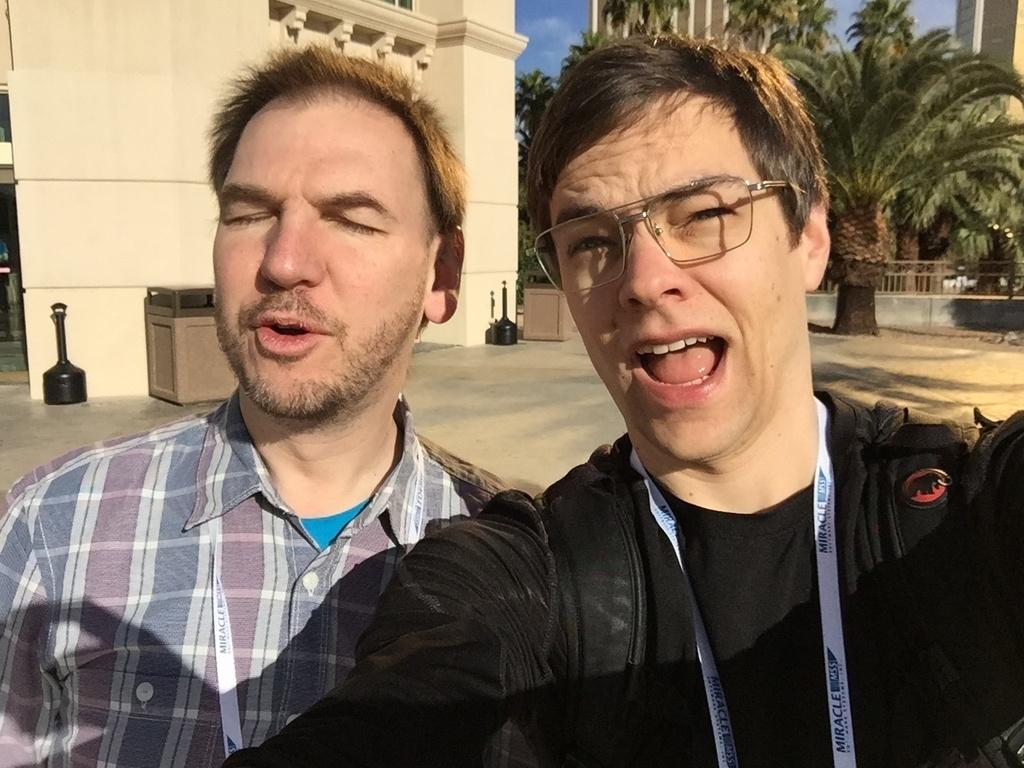How many people are in the image? There are two men in the image. Can you describe the appearance of one of the men? The man on the right side is wearing spectacles. What can be seen in the background of the image? There are buildings, trees, and a fence in the background of the image. What type of truck can be seen driving through the image? There is no truck present in the image. How does the chance of rain affect the men in the image? The image does not provide any information about the weather or the chance of rain, so we cannot determine its effect on the men. 